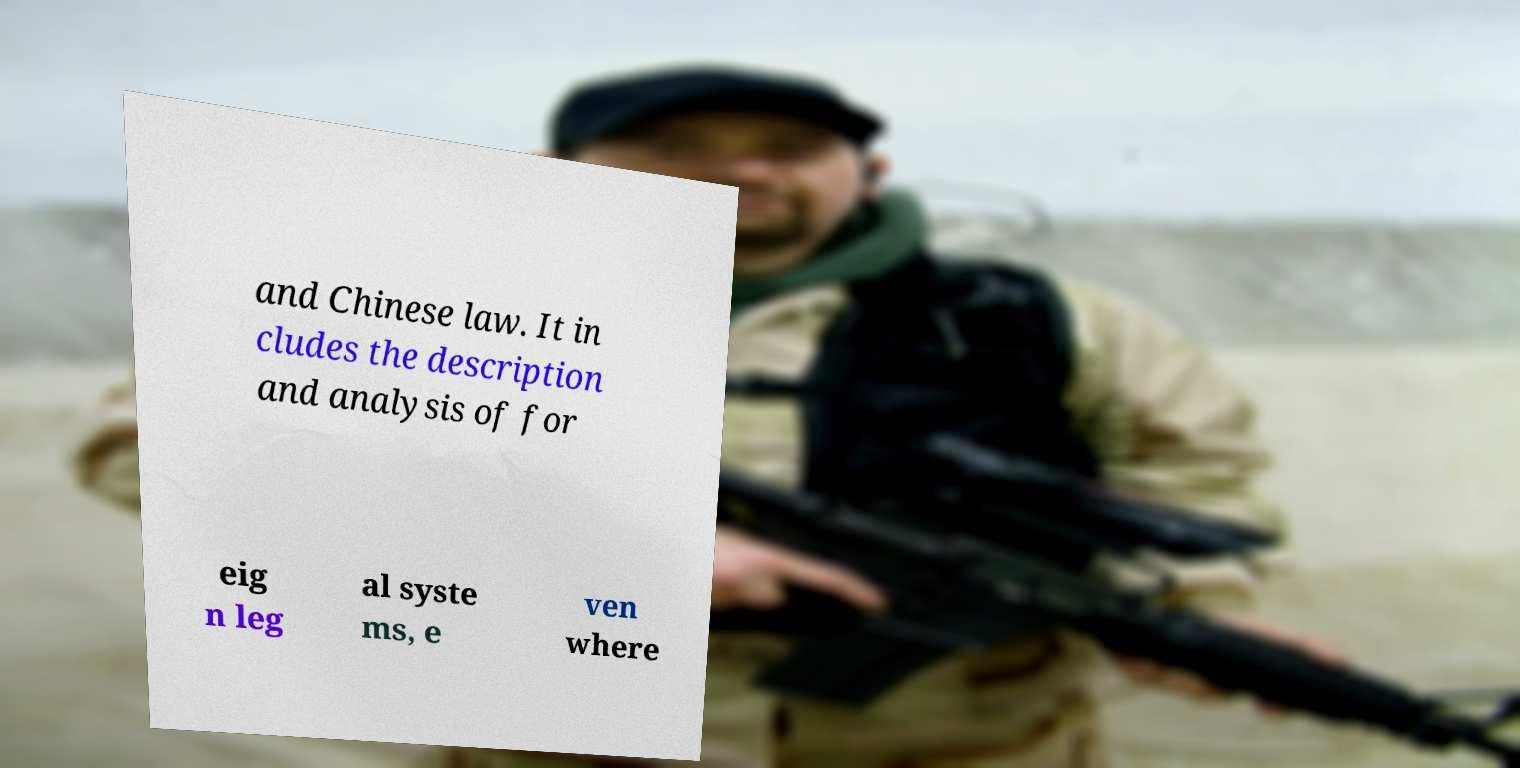Can you accurately transcribe the text from the provided image for me? and Chinese law. It in cludes the description and analysis of for eig n leg al syste ms, e ven where 